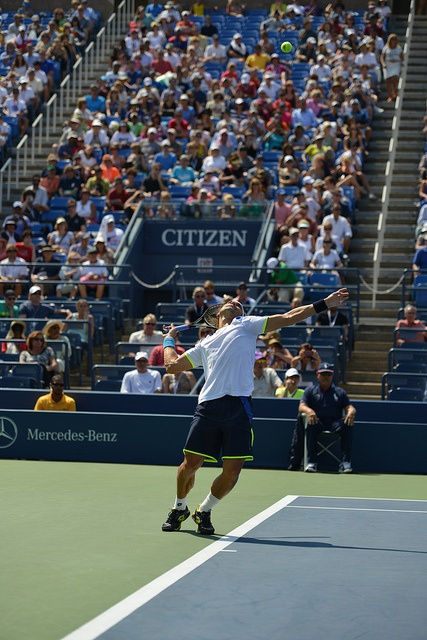Describe the objects in this image and their specific colors. I can see people in black, gray, maroon, and navy tones, chair in black, navy, gray, and darkblue tones, people in black, gray, maroon, and darkgray tones, people in black, gray, and navy tones, and people in black, gray, lightgray, and darkgray tones in this image. 